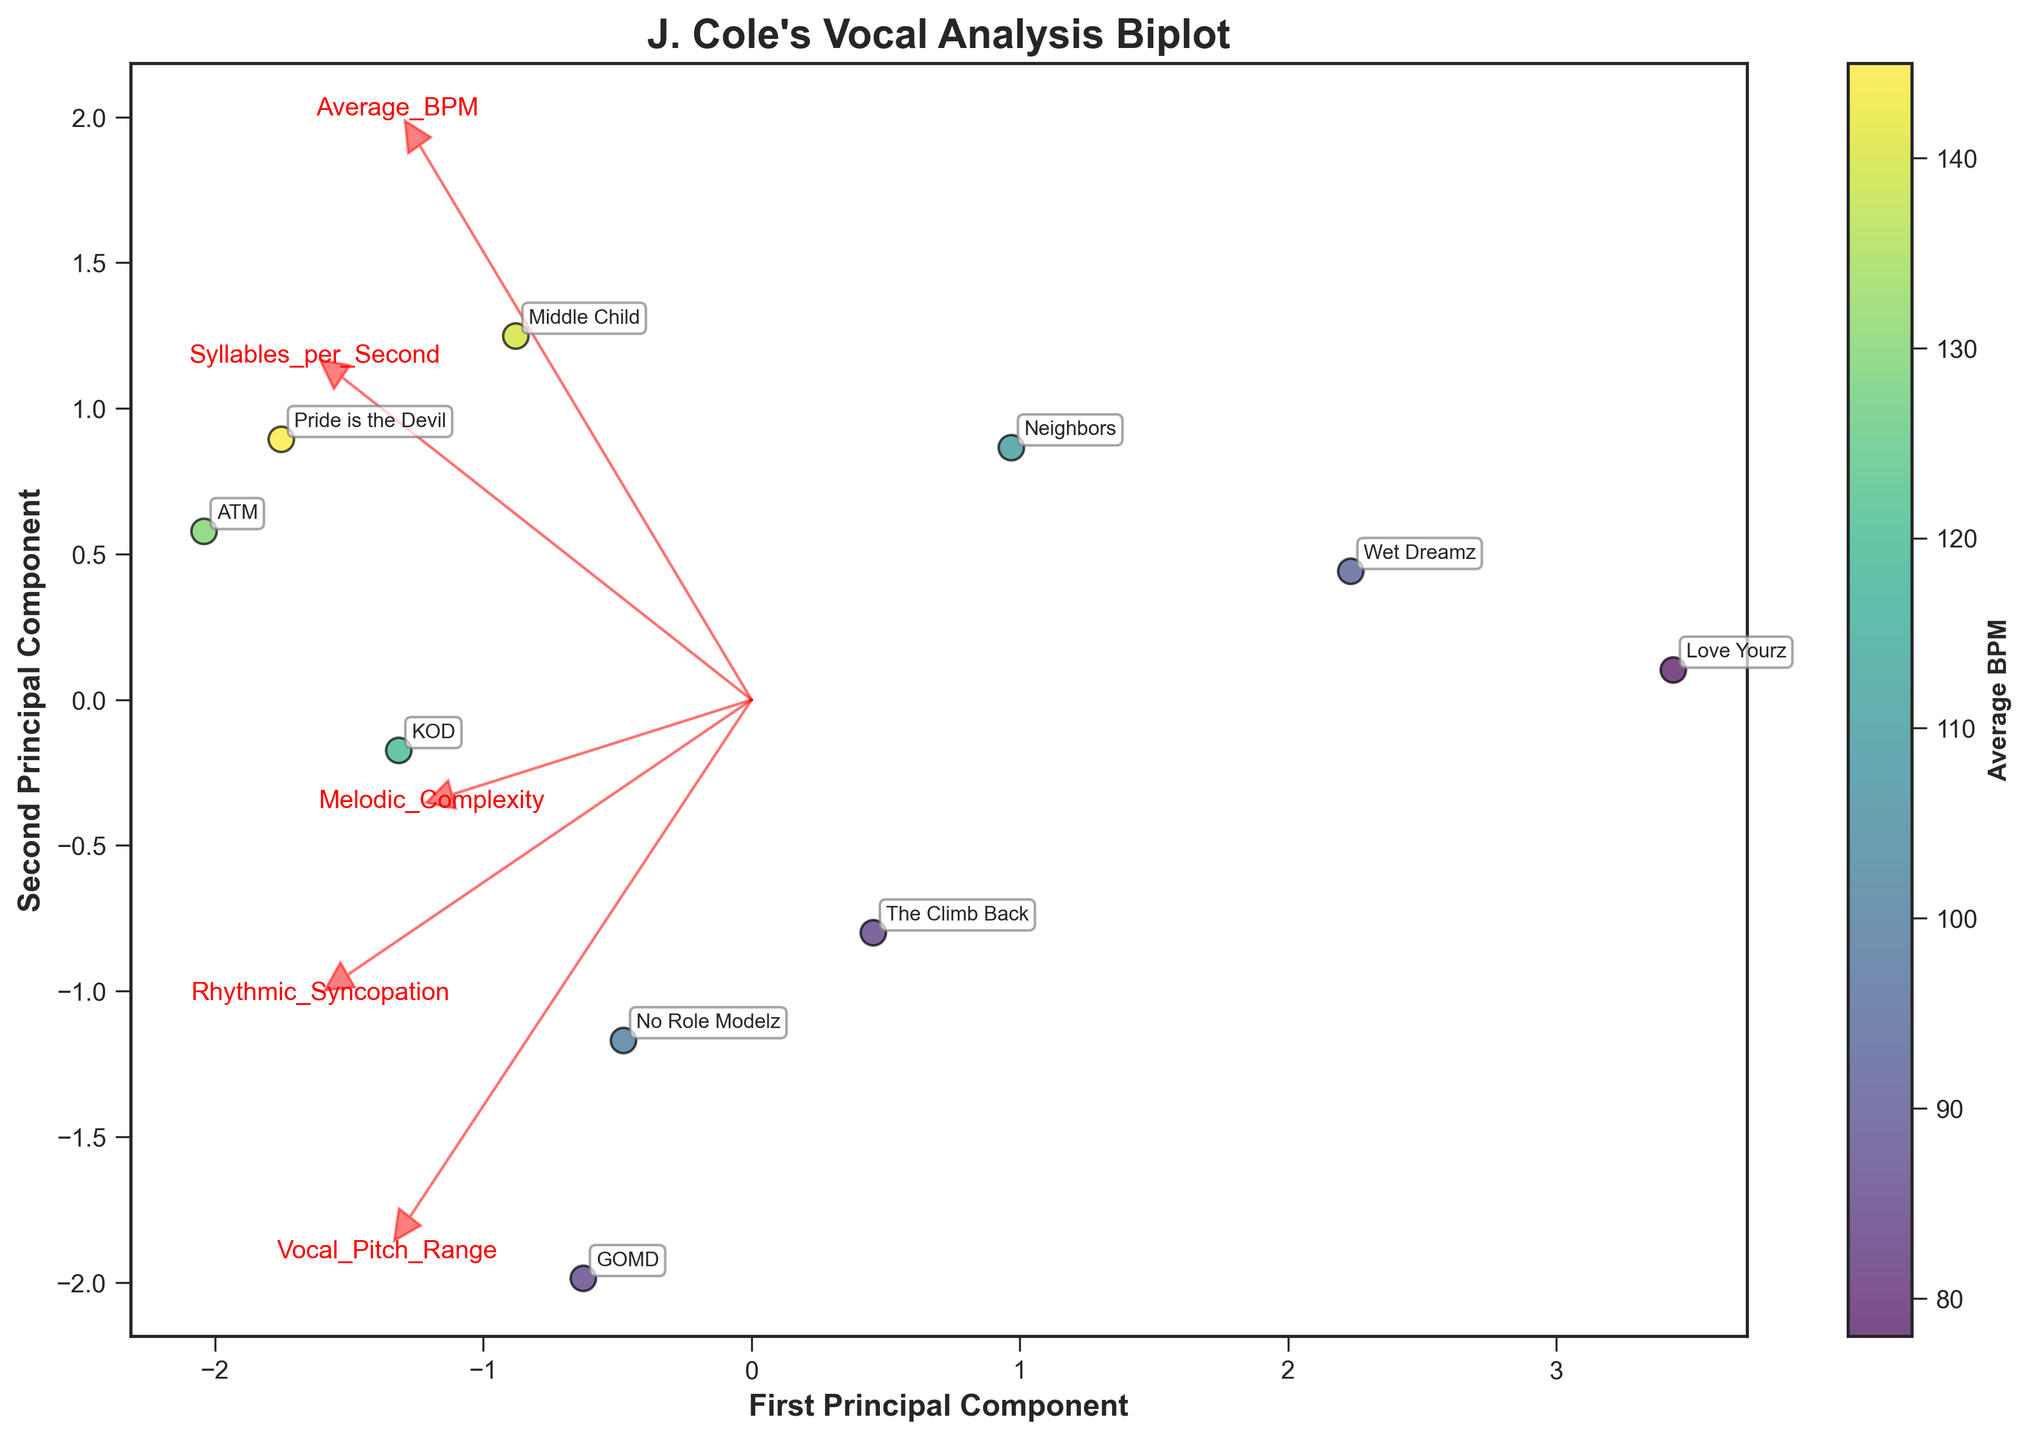What is the title of the biplot? The title is usually displayed at the top of the figure and encapsulates the main topic or focus of the visualization. In this case, it can be easily seen.
Answer: "J. Cole's Vocal Analysis Biplot" How many tracks were analyzed in the biplot? The number of tracks analyzed can be determined by counting the distinct data points represented on the biplot. Each point is labeled with a track name.
Answer: 10 Which track has the highest Average BPM? The color of each data point represents the Average BPM. The track with the darkest shade indicates the highest BPM.
Answer: "Pride is the Devil" Which feature appears to be most strongly correlated with the first principal component? The direction and length of the arrow vectors on the biplot indicate the correlation with the principal components. The vector most aligned with the x-axis and longest in length indicates the strongest correlation with the first principal component.
Answer: "Average BPM" Which two tracks have the closest positions in the biplot? Analyzing the relative positions of each point, find the two points that are nearest to each other on the graph.
Answer: "The Climb Back" and "Wet Dreamz" How does "Love Yourz" compare to "GOMD" in terms of vocal pitch range and rhythmic syncopation? First, locate both tracks on the biplot. Each arrow indicates a specific feature, and their positions relative to the arrow's direction show the comparative values for the features. "GOMD" has a higher vocal pitch range and rhythmic syncopation since it is positioned further in the direction of these feature vectors compared to "Love Yourz".
Answer: "Love Yourz" has lower vocal pitch range and rhythmic syncopation than "GOMD" Which principal component has the largest eigenvalue? This is usually derived from the variance explained by each principal component. The principal component with the longest projection lines would typically have the largest eigenvalue, representing the most variance.
Answer: First Principal Component What are the two key features that differentiate "ATM" from "Love Yourz"? Locate both "ATM" and "Love Yourz" on the biplot, compare their relative positions with respect to the feature vectors, and identify key features around which their positions differ. "ATM" has higher Melodic Complexity and Average BPM compared to "Love Yourz".
Answer: "Melodic Complexity" and "Average BPM" Which track is most associated with high Syllables per Second and high Rhythmic Syncopation? Look at the direction of the arrows for 'Syllables per Second' and 'Rhythmic Syncopation'. The track closest to where these arrows point indicates high values.
Answer: "ATM" What does the arrow direction and length for 'Vocal Pitch Range' suggest? The direction of the arrow shows the principal component it correlates with, and the length suggests the strength of that correlation. A longer arrow indicates a stronger association with one of the principal components. In this case, it suggests it is moderately correlated with both components, as the arrow is not very long but not the shortest either.
Answer: Moderately correlated with both components 